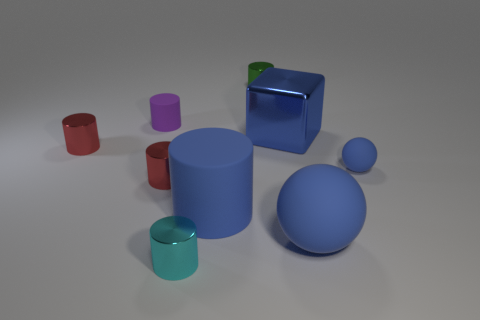What shape is the tiny cyan metal thing?
Offer a very short reply. Cylinder. How many objects are either tiny metal objects to the left of the tiny purple rubber cylinder or small cyan shiny objects?
Provide a short and direct response. 2. How many other things are the same color as the big cylinder?
Offer a terse response. 3. There is a small matte sphere; is its color the same as the large object that is behind the tiny blue thing?
Provide a short and direct response. Yes. There is a large thing that is the same shape as the small cyan object; what color is it?
Offer a very short reply. Blue. Is the material of the purple cylinder the same as the large blue object that is left of the large blue metallic thing?
Make the answer very short. Yes. The small rubber cylinder has what color?
Your answer should be compact. Purple. There is a large object in front of the large blue rubber object that is behind the large object that is on the right side of the block; what color is it?
Your response must be concise. Blue. There is a tiny purple rubber object; does it have the same shape as the small rubber object right of the cyan object?
Make the answer very short. No. What color is the matte object that is in front of the purple object and on the left side of the large block?
Your answer should be very brief. Blue. 